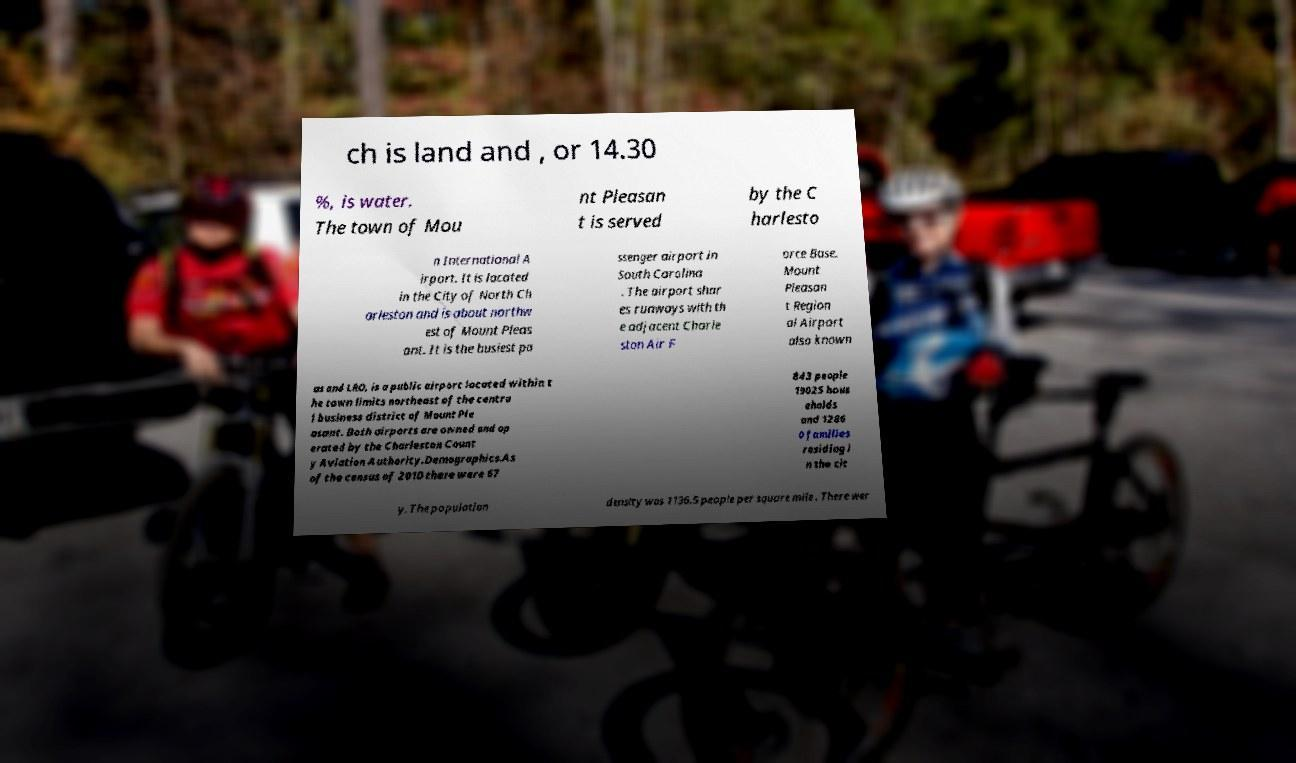What messages or text are displayed in this image? I need them in a readable, typed format. ch is land and , or 14.30 %, is water. The town of Mou nt Pleasan t is served by the C harlesto n International A irport. It is located in the City of North Ch arleston and is about northw est of Mount Pleas ant. It is the busiest pa ssenger airport in South Carolina . The airport shar es runways with th e adjacent Charle ston Air F orce Base. Mount Pleasan t Region al Airport also known as and LRO, is a public airport located within t he town limits northeast of the centra l business district of Mount Ple asant. Both airports are owned and op erated by the Charleston Count y Aviation Authority.Demographics.As of the census of 2010 there were 67 843 people 19025 hous eholds and 1286 0 families residing i n the cit y. The population density was 1136.5 people per square mile . There wer 